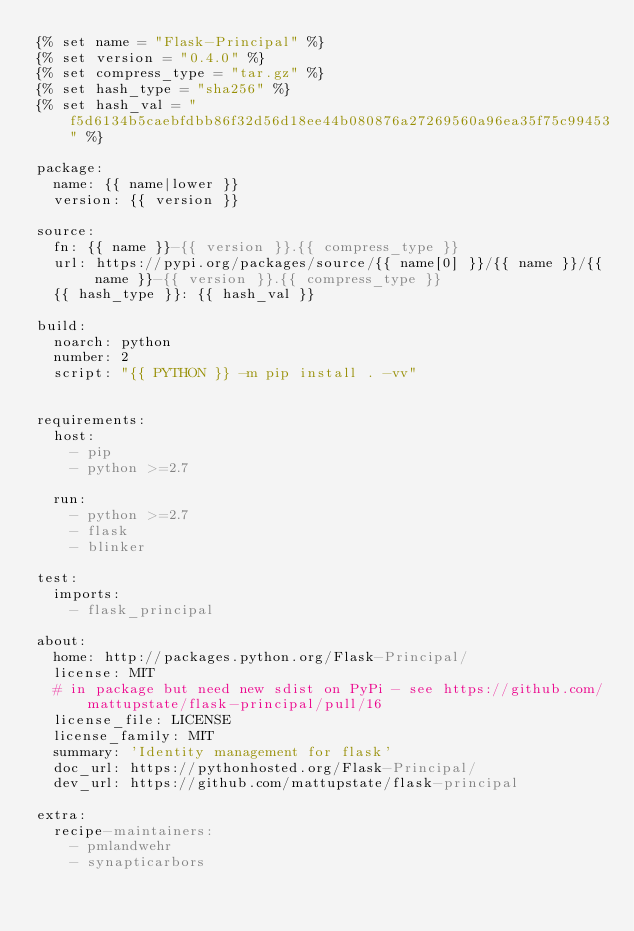Convert code to text. <code><loc_0><loc_0><loc_500><loc_500><_YAML_>{% set name = "Flask-Principal" %}
{% set version = "0.4.0" %}
{% set compress_type = "tar.gz" %}
{% set hash_type = "sha256" %}
{% set hash_val = "f5d6134b5caebfdbb86f32d56d18ee44b080876a27269560a96ea35f75c99453" %}

package:
  name: {{ name|lower }}
  version: {{ version }}

source:
  fn: {{ name }}-{{ version }}.{{ compress_type }}
  url: https://pypi.org/packages/source/{{ name[0] }}/{{ name }}/{{ name }}-{{ version }}.{{ compress_type }}
  {{ hash_type }}: {{ hash_val }}

build:
  noarch: python
  number: 2
  script: "{{ PYTHON }} -m pip install . -vv"


requirements:
  host:
    - pip
    - python >=2.7

  run:
    - python >=2.7
    - flask
    - blinker

test:
  imports:
    - flask_principal

about:
  home: http://packages.python.org/Flask-Principal/
  license: MIT
  # in package but need new sdist on PyPi - see https://github.com/mattupstate/flask-principal/pull/16
  license_file: LICENSE 
  license_family: MIT
  summary: 'Identity management for flask'
  doc_url: https://pythonhosted.org/Flask-Principal/
  dev_url: https://github.com/mattupstate/flask-principal

extra:
  recipe-maintainers:
    - pmlandwehr
    - synapticarbors
</code> 